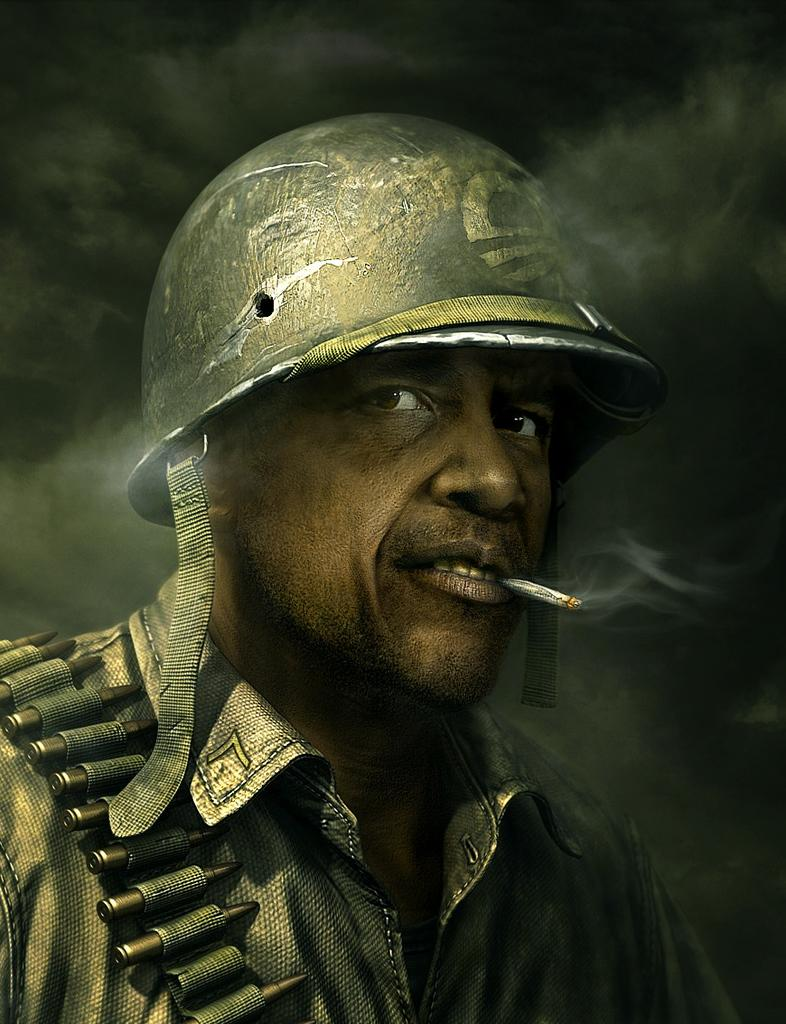Who is the main subject in the image? There is a man in the image. What is the man wearing on his head? The man is wearing a helmet. What is the man holding in his mouth? There is a cigarette in the man's mouth. What type of accessory is the man wearing on his left side? The man has a bullet belt on his left side. What can be observed about the lighting in the image? The background of the image is dark. What type of tax can be seen being collected in the image? There is no indication of tax collection in the image; it features a man wearing a helmet, a cigarette in his mouth, and a bullet belt on his left side. How many planes are visible in the image? There are no planes visible in the image. 